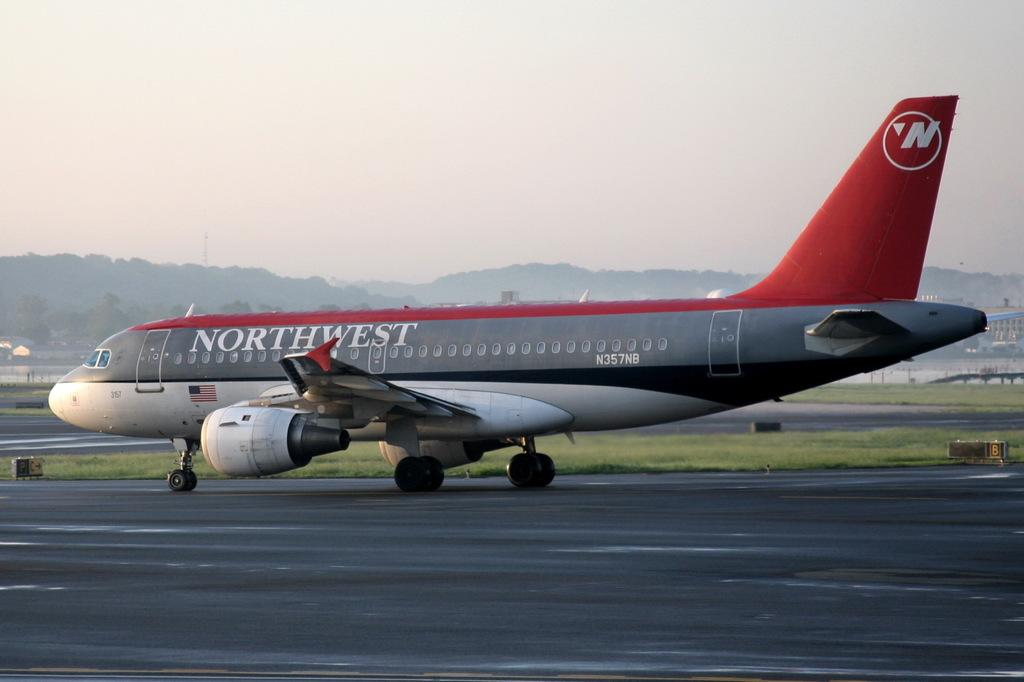Provide a one-sentence caption for the provided image. northwest airplane on the ramp ready to take off. 